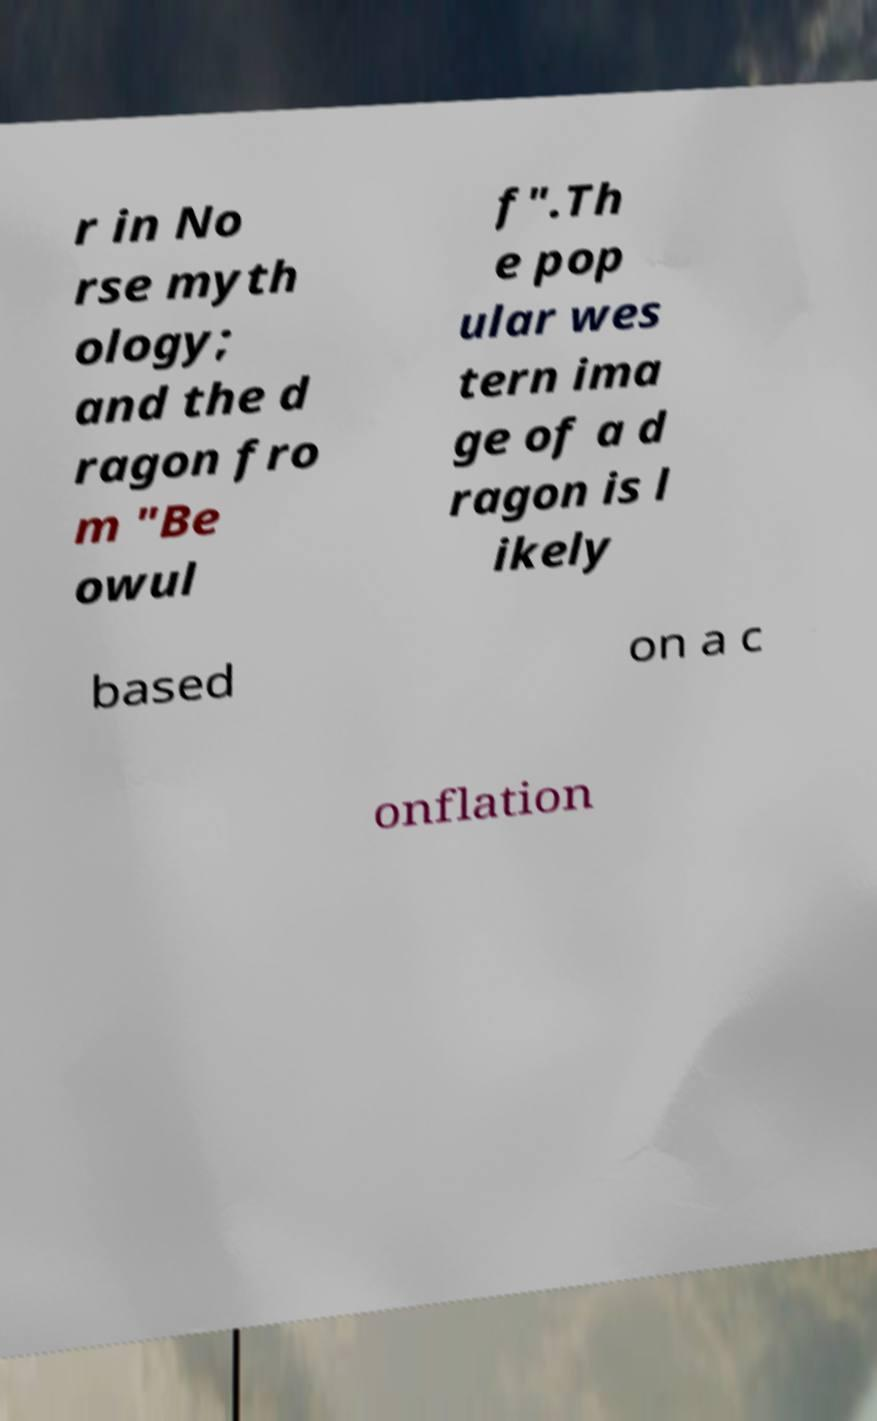Please read and relay the text visible in this image. What does it say? r in No rse myth ology; and the d ragon fro m "Be owul f".Th e pop ular wes tern ima ge of a d ragon is l ikely based on a c onflation 